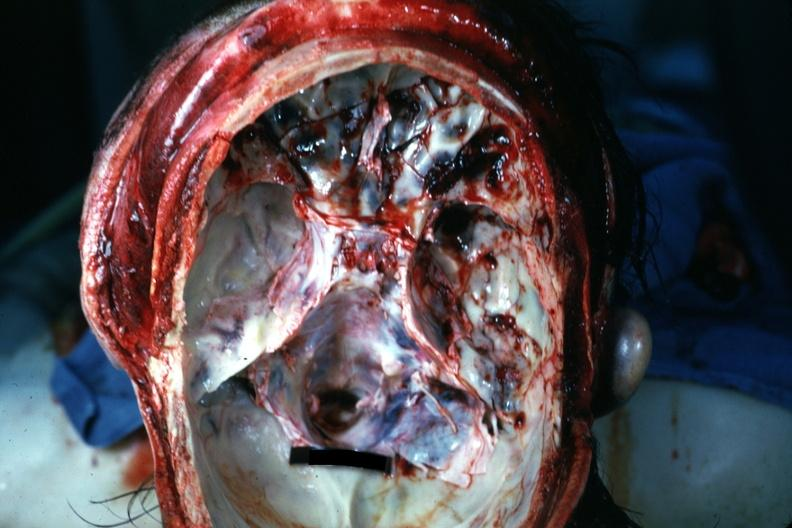does yellow color show opened cranial vault with many frontal and right temporal fossa fractures?
Answer the question using a single word or phrase. No 